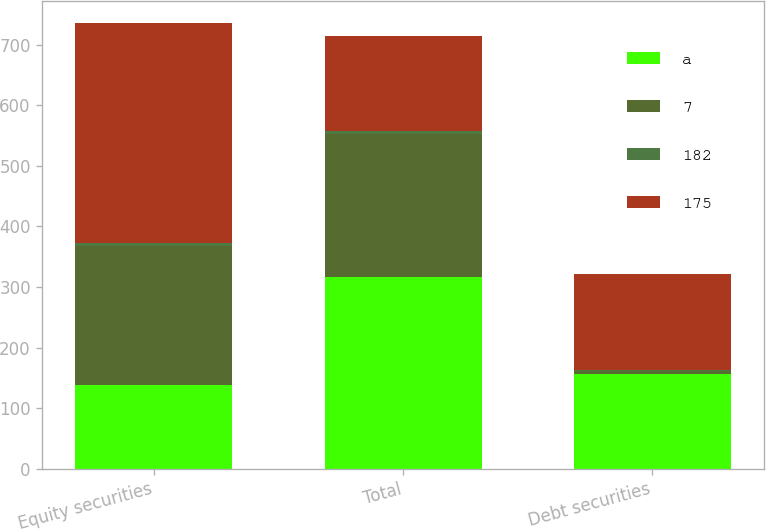Convert chart to OTSL. <chart><loc_0><loc_0><loc_500><loc_500><stacked_bar_chart><ecel><fcel>Equity securities<fcel>Total<fcel>Debt securities<nl><fcel>a<fcel>138<fcel>316<fcel>157<nl><fcel>7<fcel>230<fcel>237<fcel>4<nl><fcel>182<fcel>4<fcel>4<fcel>2<nl><fcel>175<fcel>364<fcel>157<fcel>159<nl></chart> 